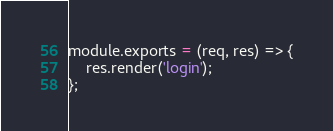<code> <loc_0><loc_0><loc_500><loc_500><_JavaScript_>module.exports = (req, res) => {
    res.render('login');
};

</code> 